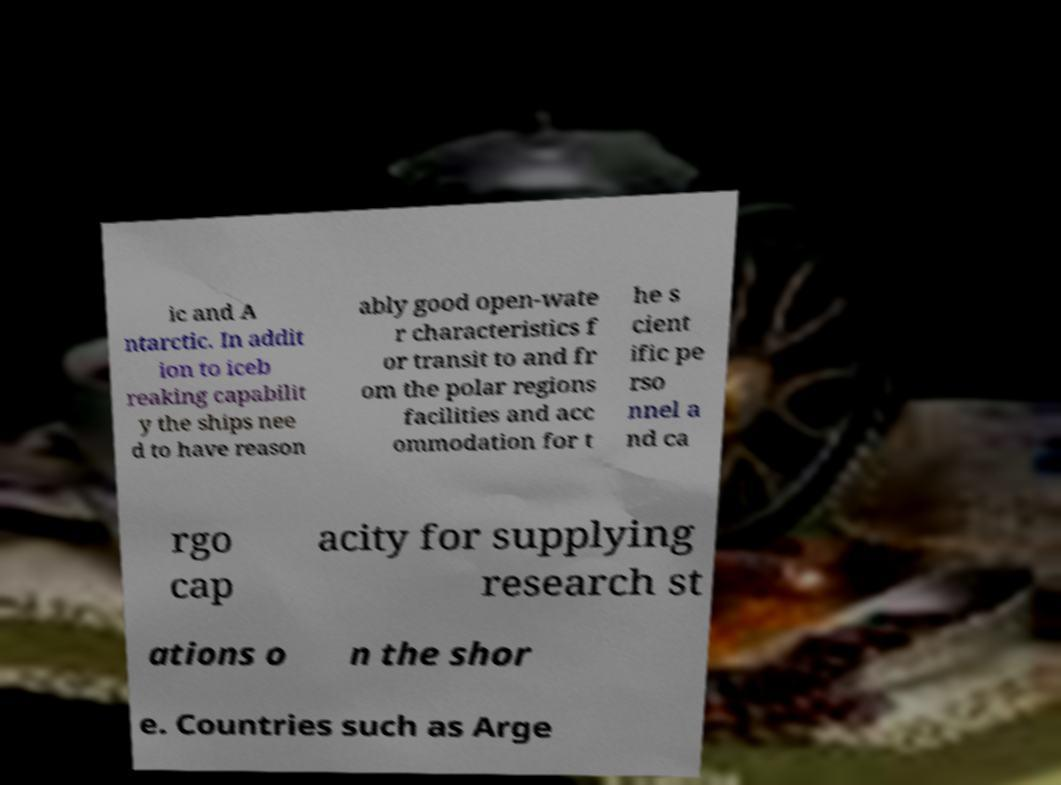I need the written content from this picture converted into text. Can you do that? ic and A ntarctic. In addit ion to iceb reaking capabilit y the ships nee d to have reason ably good open-wate r characteristics f or transit to and fr om the polar regions facilities and acc ommodation for t he s cient ific pe rso nnel a nd ca rgo cap acity for supplying research st ations o n the shor e. Countries such as Arge 